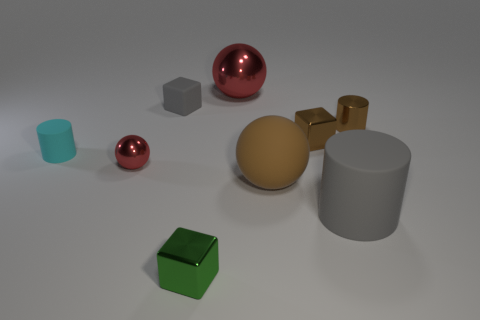The small metallic block behind the tiny red ball is what color?
Give a very brief answer. Brown. How many other things are there of the same color as the tiny rubber block?
Offer a terse response. 1. Is the size of the rubber cylinder that is on the right side of the brown ball the same as the matte block?
Your answer should be compact. No. There is a brown cylinder that is to the right of the green metallic cube; what is its material?
Your answer should be compact. Metal. Is there any other thing that has the same shape as the cyan object?
Your answer should be compact. Yes. What number of rubber things are either large red spheres or small cyan cylinders?
Offer a very short reply. 1. Is the number of small brown metallic cylinders in front of the large metallic object less than the number of metal blocks?
Your answer should be very brief. Yes. There is a gray object in front of the gray rubber object that is behind the metallic object that is on the left side of the green metal object; what is its shape?
Your answer should be very brief. Cylinder. Do the large metal thing and the small sphere have the same color?
Provide a succinct answer. Yes. Is the number of red shiny balls greater than the number of green spheres?
Give a very brief answer. Yes. 